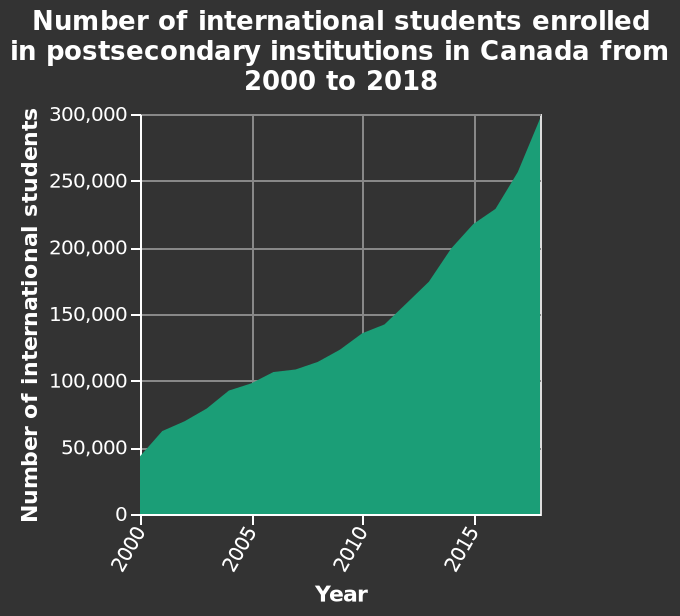<image>
What does the x-axis represent in the line diagram? The x-axis represents the years from 2000 to 2015. What does the area plot titled?  The area plot is titled "Number of international students enrolled in postsecondary institutions in Canada from 2000 to 2018." What is the range of the y-axis?  The range of the y-axis is from 0 to 300,000. please describe the details of the chart Here a area plot is titled Number of international students enrolled in postsecondary institutions in Canada from 2000 to 2018. The y-axis measures Number of international students as linear scale from 0 to 300,000 while the x-axis measures Year using linear scale of range 2000 to 2015. Is the range of the y-axis from 0 to 50,000? No.The range of the y-axis is from 0 to 300,000. 